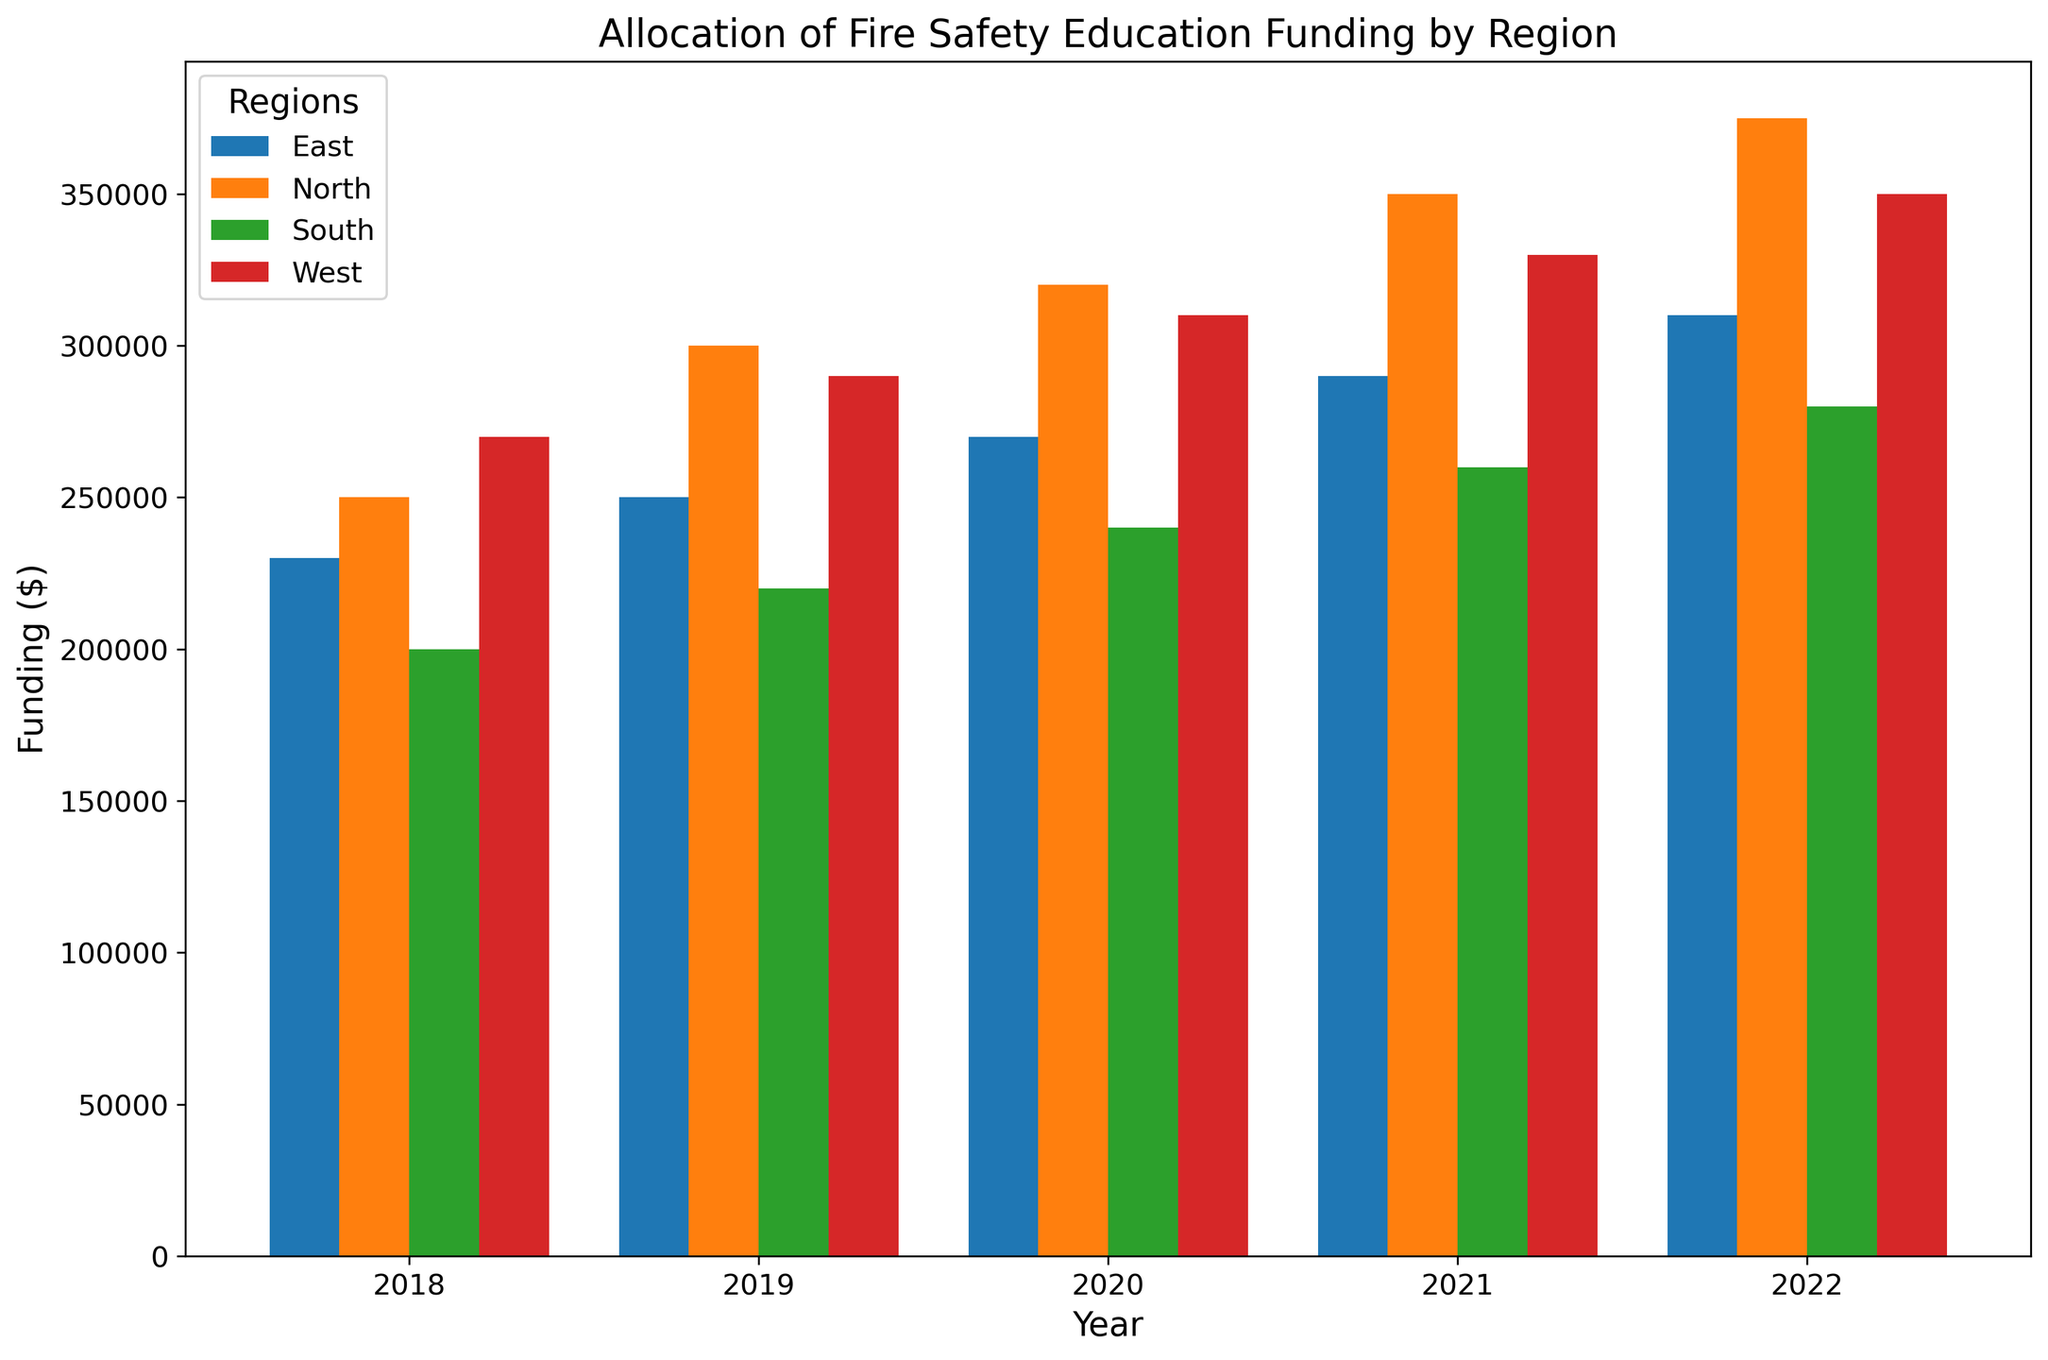Which region received the highest funding in 2022? The tallest bar in 2022 is for the North region, indicating that it received the highest funding, which is $375,000.
Answer: North Which two regions had an equal amount of funding in 2021? By comparing the heights of the bars and their values in 2021, it's evident that both the North and West regions have bars of the same height, which is $350,000.
Answer: North and West What is the total funding received by the South region over the five years? Sum the heights of the bars for the South region for each year: $200,000 (2018) + $220,000 (2019) + $240,000 (2020) + $260,000 (2021) + $280,000 (2022) = $1,200,000.
Answer: $1,200,000 How much more funding did the North region receive compared to the South region in 2020? Subtract the South region's funding from the North region's funding in 2020: $320,000 (North) - $240,000 (South) = $80,000.
Answer: $80,000 Which year showed the least difference in funding between the East and West regions? By comparing the bars for East and West across all years, 2018 shows the smallest difference: $270,000 (West) - $230,000 (East) = $40,000.
Answer: 2018 What is the average funding allocated to the East region over the five years? Sum the fundings for the East region and then divide by 5: ($230,000 + $250,000 + $270,000 + $290,000 + $310,000) / 5 = $1,350,000 / 5 = $270,000.
Answer: $270,000 Which region experienced the most consistent increase in funding every year from 2018 to 2022? By observing the bar heights for each region over the years, the South region shows a consistent and equal increase of $20,000 each year.
Answer: South In 2019, which region had the second-highest funding? By comparing the bar heights for 2019, the second-highest bar is for the West region with $290,000.
Answer: West What was the percentage increase in funding for the North region from 2018 to 2022? Calculate the percentage increase using the formula ((New Value - Old Value) / Old Value) * 100%. For North: (($375,000 - $250,000) / $250,000) * 100% = 50%.
Answer: 50% How much total funding was allocated across all regions in 2022? Sum the fundings for each region in 2022: $375,000 (North) + $280,000 (South) + $310,000 (East) + $350,000 (West) = $1,315,000.
Answer: $1,315,000 